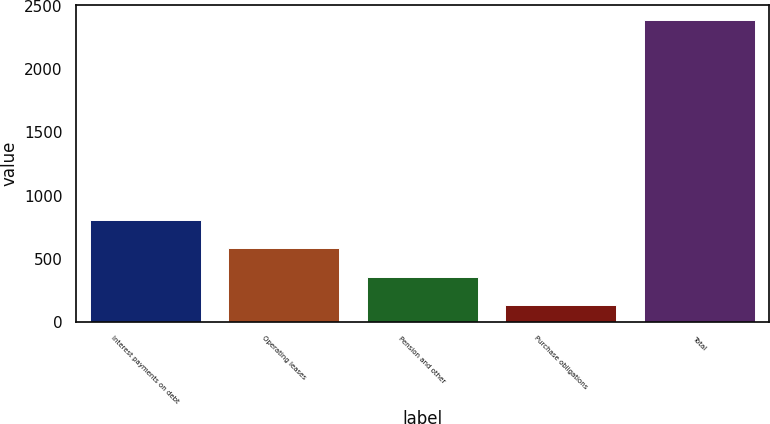Convert chart. <chart><loc_0><loc_0><loc_500><loc_500><bar_chart><fcel>Interest payments on debt<fcel>Operating leases<fcel>Pension and other<fcel>Purchase obligations<fcel>Total<nl><fcel>809.4<fcel>583.6<fcel>357.8<fcel>132<fcel>2390<nl></chart> 